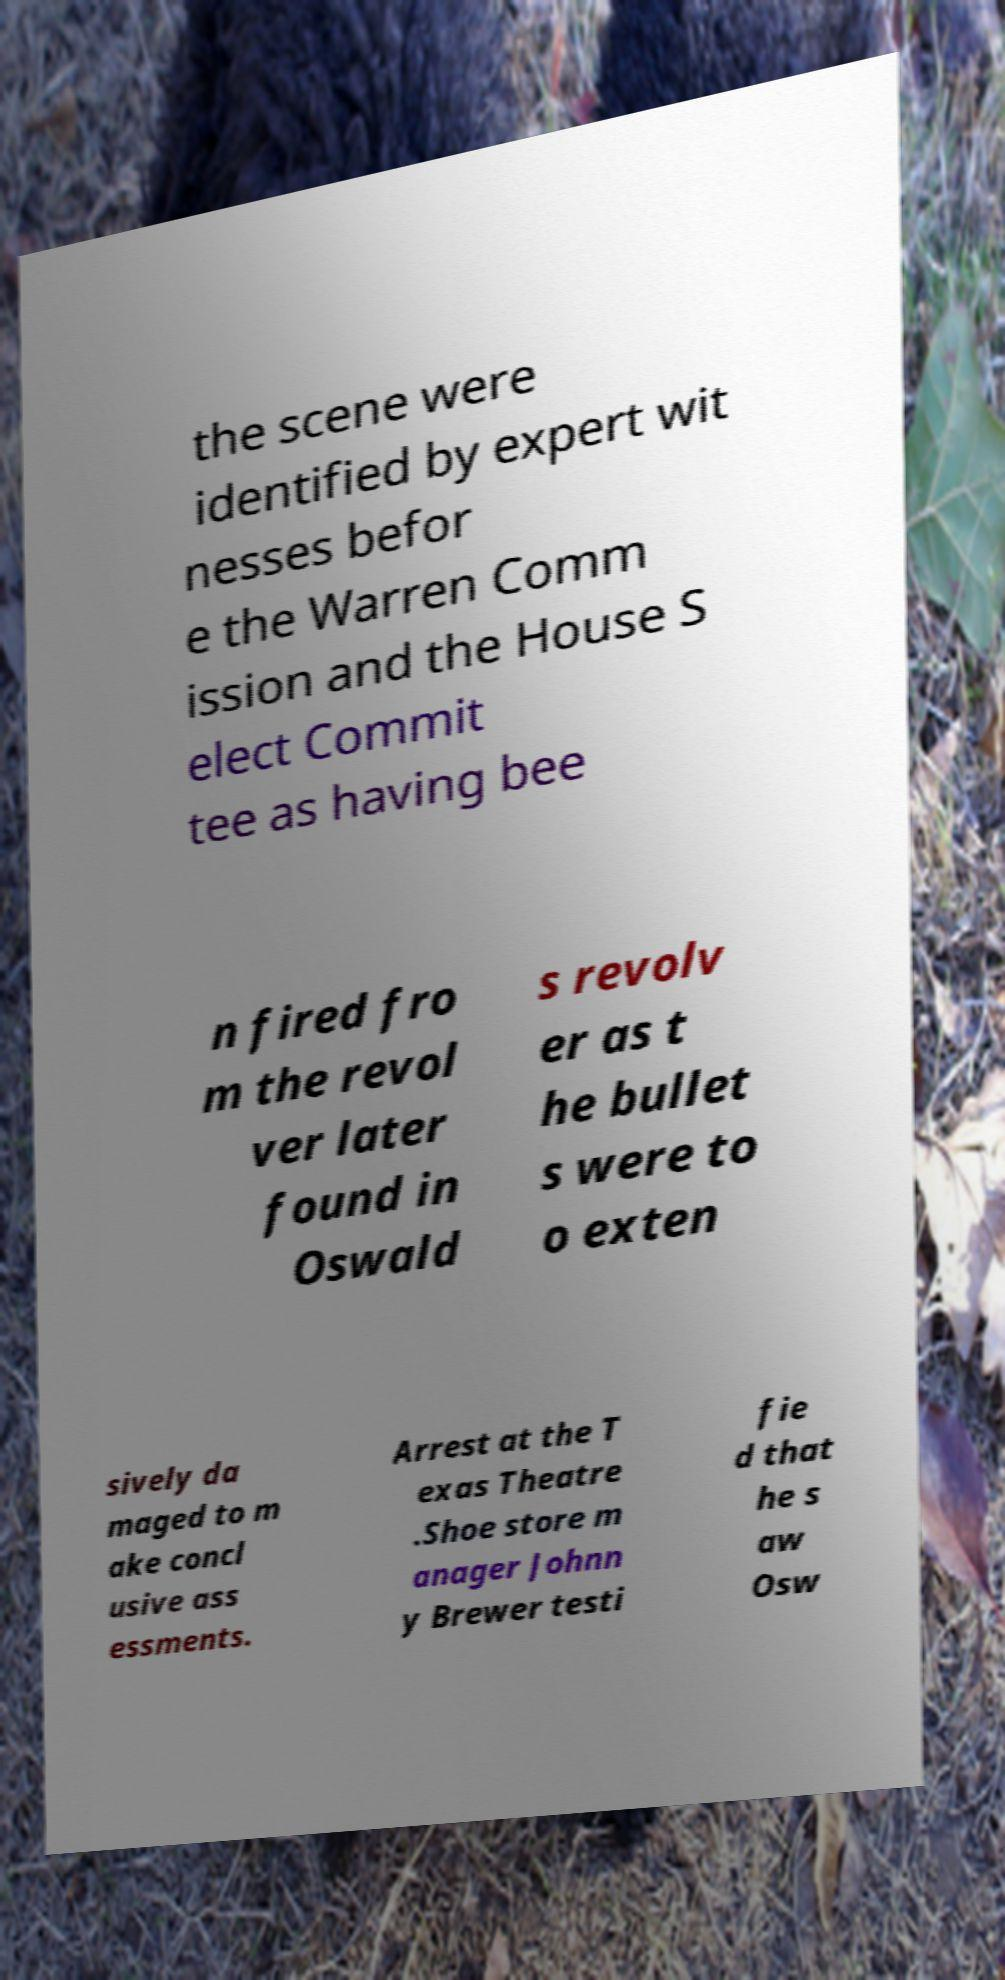What messages or text are displayed in this image? I need them in a readable, typed format. the scene were identified by expert wit nesses befor e the Warren Comm ission and the House S elect Commit tee as having bee n fired fro m the revol ver later found in Oswald s revolv er as t he bullet s were to o exten sively da maged to m ake concl usive ass essments. Arrest at the T exas Theatre .Shoe store m anager Johnn y Brewer testi fie d that he s aw Osw 